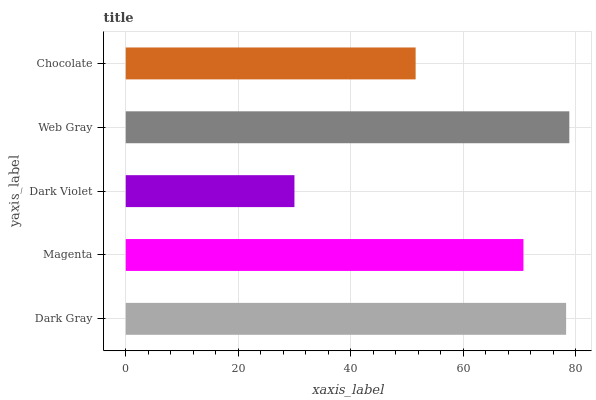Is Dark Violet the minimum?
Answer yes or no. Yes. Is Web Gray the maximum?
Answer yes or no. Yes. Is Magenta the minimum?
Answer yes or no. No. Is Magenta the maximum?
Answer yes or no. No. Is Dark Gray greater than Magenta?
Answer yes or no. Yes. Is Magenta less than Dark Gray?
Answer yes or no. Yes. Is Magenta greater than Dark Gray?
Answer yes or no. No. Is Dark Gray less than Magenta?
Answer yes or no. No. Is Magenta the high median?
Answer yes or no. Yes. Is Magenta the low median?
Answer yes or no. Yes. Is Dark Gray the high median?
Answer yes or no. No. Is Dark Violet the low median?
Answer yes or no. No. 